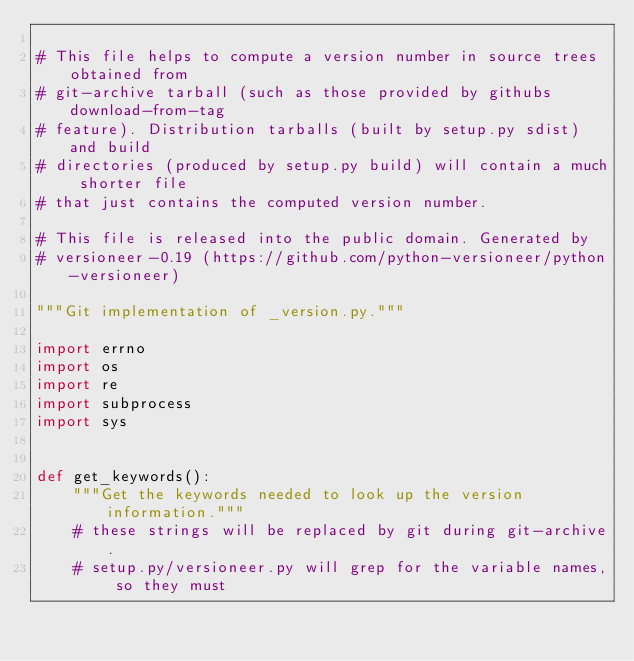<code> <loc_0><loc_0><loc_500><loc_500><_Python_>
# This file helps to compute a version number in source trees obtained from
# git-archive tarball (such as those provided by githubs download-from-tag
# feature). Distribution tarballs (built by setup.py sdist) and build
# directories (produced by setup.py build) will contain a much shorter file
# that just contains the computed version number.

# This file is released into the public domain. Generated by
# versioneer-0.19 (https://github.com/python-versioneer/python-versioneer)

"""Git implementation of _version.py."""

import errno
import os
import re
import subprocess
import sys


def get_keywords():
    """Get the keywords needed to look up the version information."""
    # these strings will be replaced by git during git-archive.
    # setup.py/versioneer.py will grep for the variable names, so they must</code> 